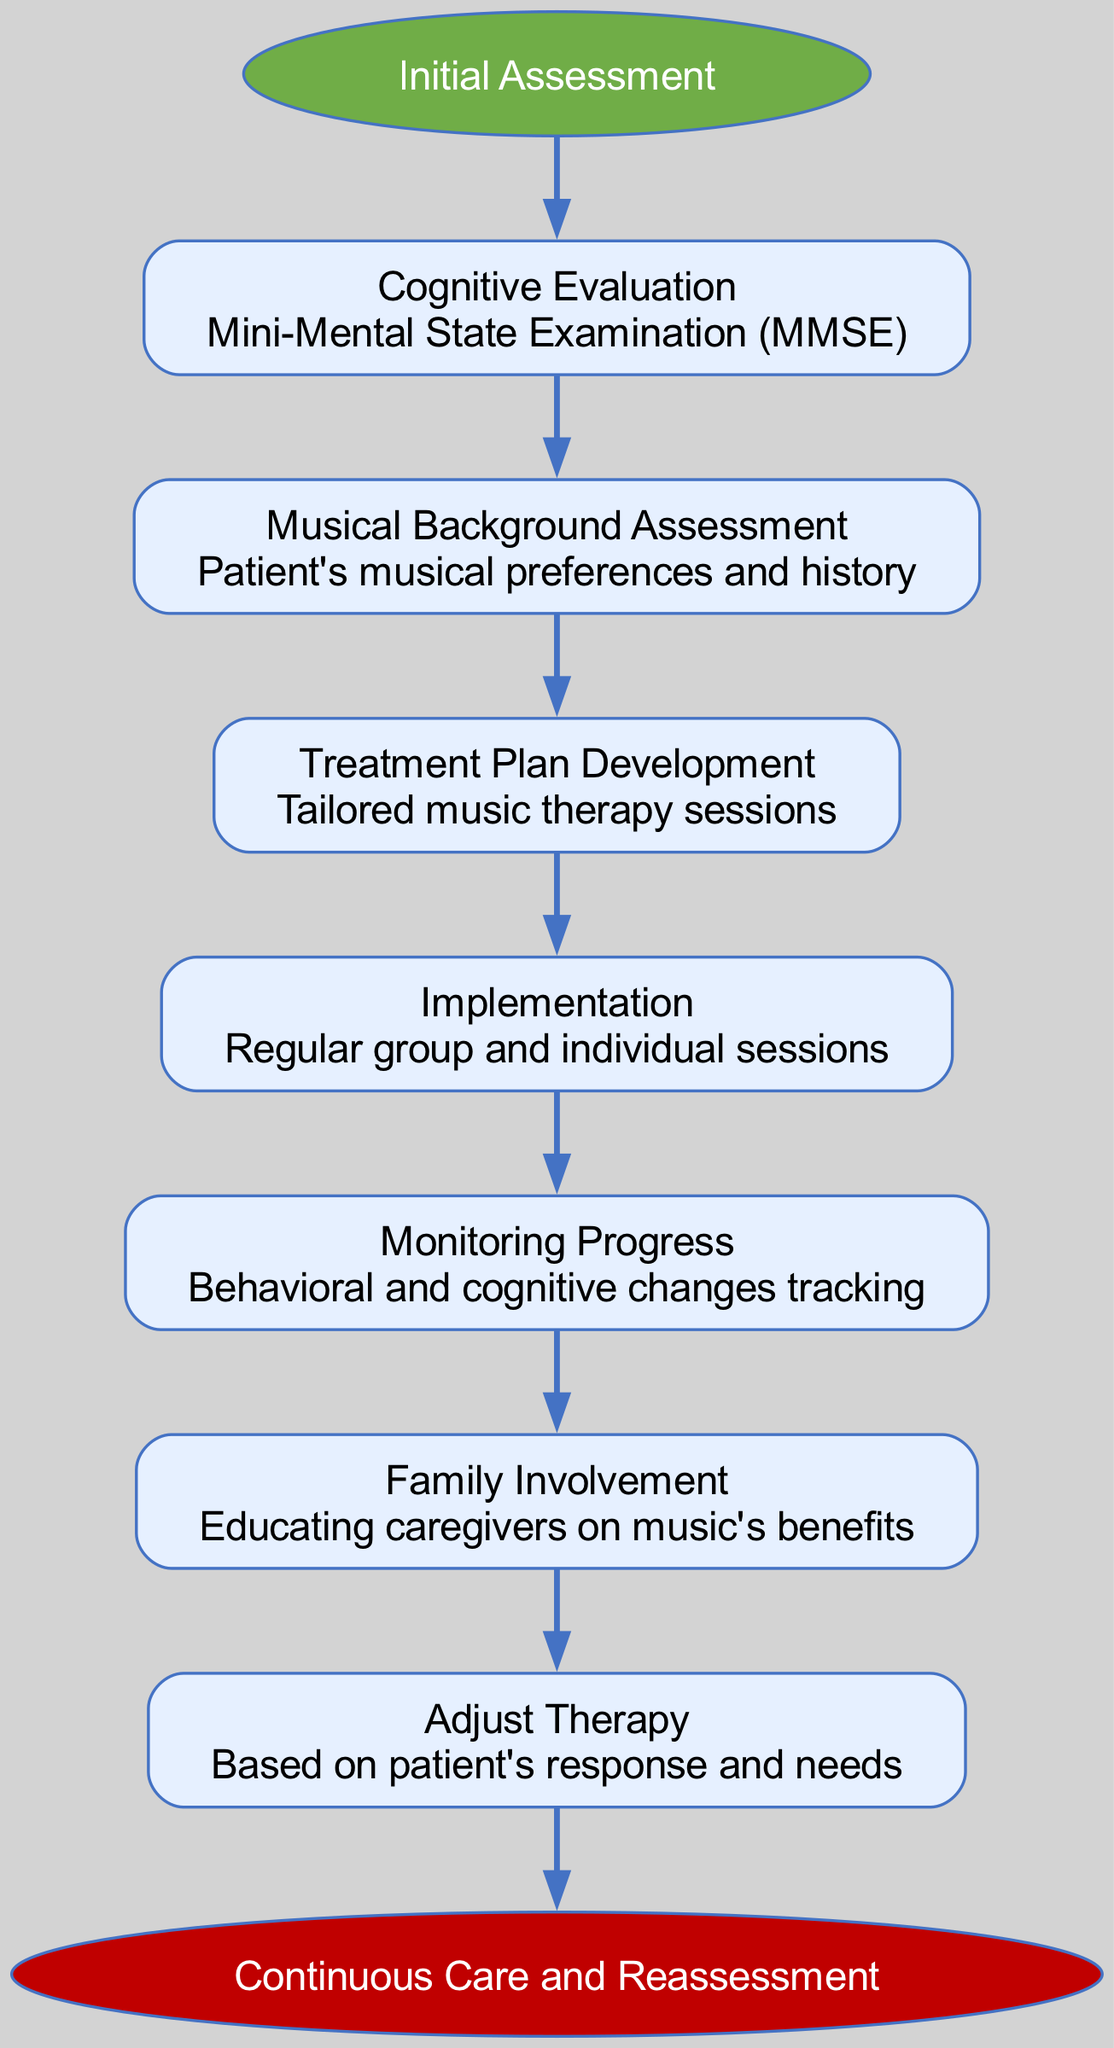What is the first step in the pathway? The diagram starts with the "Initial Assessment" node, which is the beginning of the clinical pathway. From there, the first specific step is "Cognitive Evaluation."
Answer: Cognitive Evaluation How many steps are there in total? There are a total of 7 steps listed in the diagram, following "Initial Assessment" and leading to "Continuous Care and Reassessment."
Answer: 7 What is the last step before the endpoint? The last step before reaching the endpoint "Continuous Care and Reassessment" is "Adjust Therapy," which is the final action listed before the concluding phase.
Answer: Adjust Therapy Which step involves educating caregivers? The "Family Involvement" step is specifically focused on educating caregivers about the benefits of music, making it the relevant step for this question.
Answer: Family Involvement What is the treatment plan based on? The "Treatment Plan Development" step highlights that the treatment plan is tailored for the individual, relying on the music therapy sessions developed for each patient based on their specific needs.
Answer: Tailored music therapy sessions What does the "Monitoring Progress" step track? This step is focused on tracking both behavioral and cognitive changes, which allows for assessing how well the music therapy is working for the patient.
Answer: Behavioral and cognitive changes tracking Which step follows the "Musical Background Assessment"? After the "Musical Background Assessment," the next step in the pathway is "Treatment Plan Development," indicating a progression from understanding the patient’s musical inclinations to developing a specific plan.
Answer: Treatment Plan Development How is therapy adjusted? The diagram indicates that therapy is adjusted "Based on patient's response and needs," which ensures that the approach to music therapy remains relevant and effective for each individual patient.
Answer: Based on patient's response and needs 